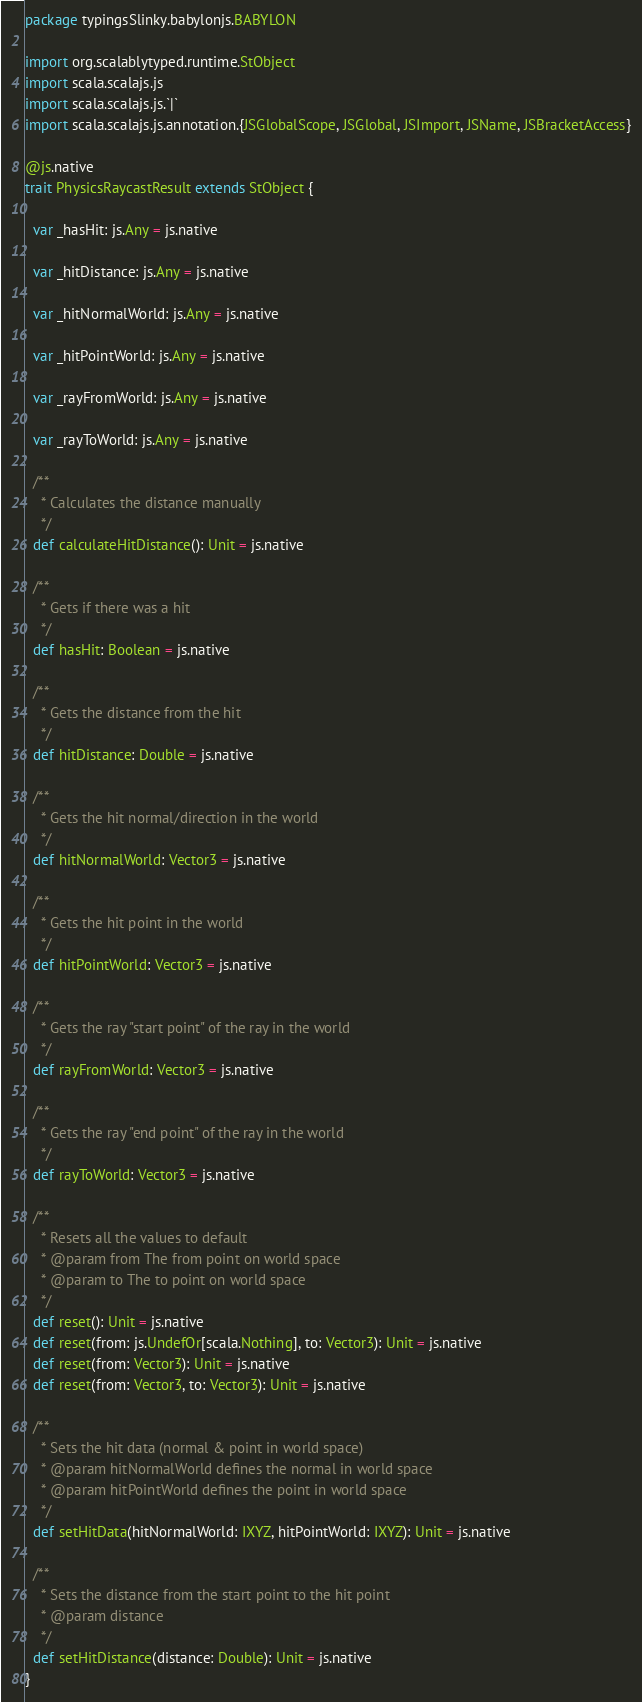Convert code to text. <code><loc_0><loc_0><loc_500><loc_500><_Scala_>package typingsSlinky.babylonjs.BABYLON

import org.scalablytyped.runtime.StObject
import scala.scalajs.js
import scala.scalajs.js.`|`
import scala.scalajs.js.annotation.{JSGlobalScope, JSGlobal, JSImport, JSName, JSBracketAccess}

@js.native
trait PhysicsRaycastResult extends StObject {
  
  var _hasHit: js.Any = js.native
  
  var _hitDistance: js.Any = js.native
  
  var _hitNormalWorld: js.Any = js.native
  
  var _hitPointWorld: js.Any = js.native
  
  var _rayFromWorld: js.Any = js.native
  
  var _rayToWorld: js.Any = js.native
  
  /**
    * Calculates the distance manually
    */
  def calculateHitDistance(): Unit = js.native
  
  /**
    * Gets if there was a hit
    */
  def hasHit: Boolean = js.native
  
  /**
    * Gets the distance from the hit
    */
  def hitDistance: Double = js.native
  
  /**
    * Gets the hit normal/direction in the world
    */
  def hitNormalWorld: Vector3 = js.native
  
  /**
    * Gets the hit point in the world
    */
  def hitPointWorld: Vector3 = js.native
  
  /**
    * Gets the ray "start point" of the ray in the world
    */
  def rayFromWorld: Vector3 = js.native
  
  /**
    * Gets the ray "end point" of the ray in the world
    */
  def rayToWorld: Vector3 = js.native
  
  /**
    * Resets all the values to default
    * @param from The from point on world space
    * @param to The to point on world space
    */
  def reset(): Unit = js.native
  def reset(from: js.UndefOr[scala.Nothing], to: Vector3): Unit = js.native
  def reset(from: Vector3): Unit = js.native
  def reset(from: Vector3, to: Vector3): Unit = js.native
  
  /**
    * Sets the hit data (normal & point in world space)
    * @param hitNormalWorld defines the normal in world space
    * @param hitPointWorld defines the point in world space
    */
  def setHitData(hitNormalWorld: IXYZ, hitPointWorld: IXYZ): Unit = js.native
  
  /**
    * Sets the distance from the start point to the hit point
    * @param distance
    */
  def setHitDistance(distance: Double): Unit = js.native
}
</code> 